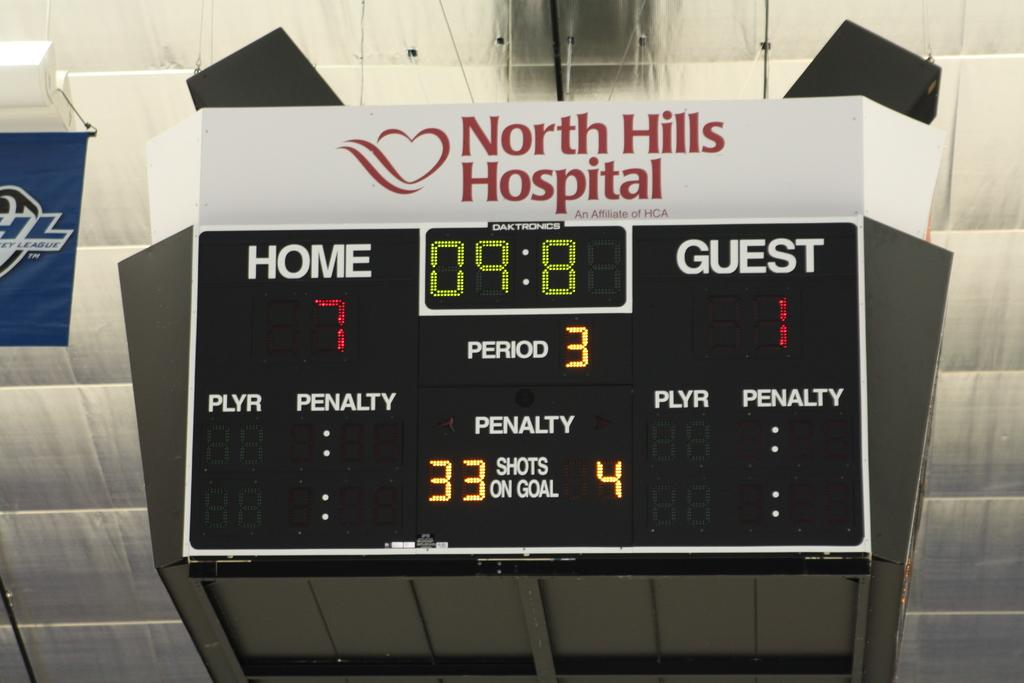<image>
Share a concise interpretation of the image provided. The electronic sign indicates the home team is leading by 6 points. 